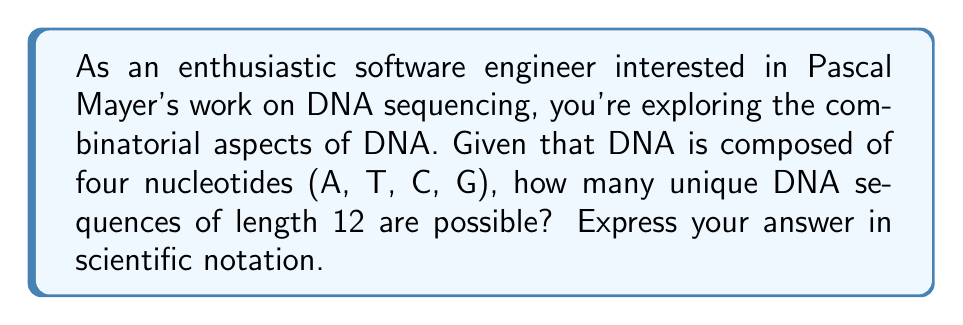Help me with this question. To solve this problem, let's break it down step-by-step:

1) First, recall that DNA is composed of four nucleotides: Adenine (A), Thymine (T), Cytosine (C), and Guanine (G).

2) For each position in the DNA sequence, we have 4 choices (A, T, C, or G).

3) The sequence has a length of 12, meaning we need to make this choice 12 times.

4) This scenario follows the multiplication principle of counting. When we have a series of independent choices, we multiply the number of options for each choice.

5) Mathematically, this can be expressed as:

   $\text{Number of sequences} = 4^{12}$

6) To calculate this:
   
   $4^{12} = 4 \times 4 \times 4 \times 4 \times 4 \times 4 \times 4 \times 4 \times 4 \times 4 \times 4 \times 4 = 16,777,216$

7) To express this in scientific notation:

   $16,777,216 = 1.6777216 \times 10^7$

This large number demonstrates the vast diversity of possible DNA sequences, which is crucial in understanding the complexity of genomics and the challenges in DNA sequencing that Pascal Mayer's work addresses.
Answer: $1.6777216 \times 10^7$ 